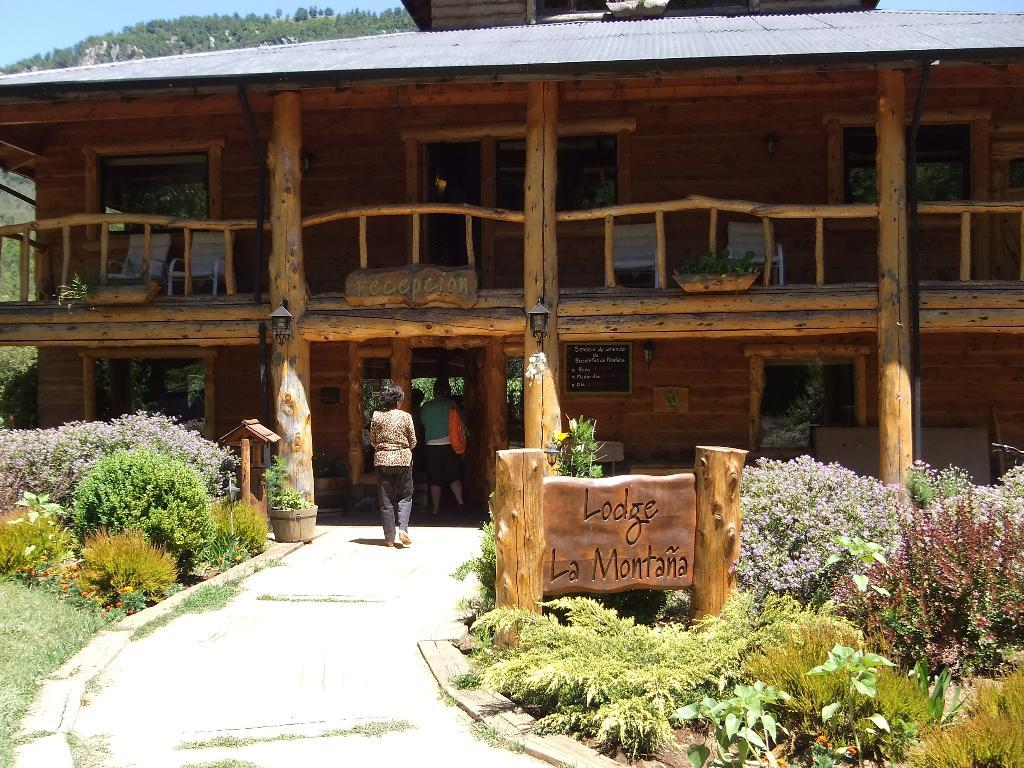<image>
Render a clear and concise summary of the photo. Person walking into a building with a sign saying Lodge La Montana. 